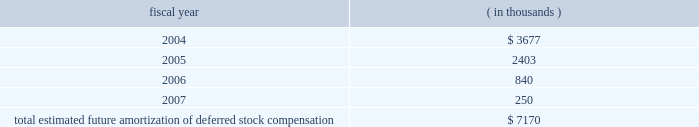The table presents the estimated future amortization of deferred stock compensation reported in both cost of revenue and operating expenses : fiscal year ( in thousands ) .
Impairment of intangible assets .
In fiscal 2002 , we recognized an aggregate impairment charge of $ 3.8 million to reduce the amount of certain intangible assets associated with prior acquisitions to their estimated fair value .
Approximately $ 3.7 million and $ 0.1 million are included in integration expense and amortization of intangible assets , respectively , on the consolidated statement of operations .
The impairment charge is primarily attributable to certain technology acquired from and goodwill related to the acquisition of stanza , inc .
( stanza ) in 1999 .
During fiscal 2002 , we determined that we would not allocate future resources to assist in the market growth of this technology as products acquired in the merger with avant! provided customers with superior capabilities .
As a result , we do not anticipate any future sales of the stanza product .
In fiscal 2001 , we recognized an aggregate impairment charge of $ 2.2 million to reduce the amount of certain intangible assets associated with prior acquisitions to their estimated fair value .
Approximately $ 1.8 million and $ 0.4 million are included in cost of revenues and amortization of intangible assets , respectively , on the consolidated statement of operations .
The impairment charge is attributable to certain technology acquired from and goodwill related to the acquisition of eagle design automation , inc .
( eagle ) in 1997 .
During fiscal 2001 , we determined that we would not allocate future resources to assist in the market growth of this technology .
As a result , we do not anticipate any future sales of the eagle product .
There were no impairment charges during fiscal 2003 .
Other ( expense ) income , net .
Other income , net was $ 24.1 million in fiscal 2003 and consisted primarily of ( i ) realized gain on investments of $ 20.7 million ; ( ii ) rental income of $ 6.3 million ; ( iii ) interest income of $ 5.2 million ; ( iv ) impairment charges related to certain assets in our venture portfolio of ( $ 4.5 ) million ; ( vii ) foundation contributions of ( $ 2.1 ) million ; and ( viii ) interest expense of ( $ 1.6 ) million .
Other ( expense ) , net of other income was ( $ 208.6 ) million in fiscal 2002 and consisted primarily of ( i ) ( $ 240.8 ) million expense due to the settlement of the cadence design systems , inc .
( cadence ) litigation ; ( ii ) ( $ 11.3 ) million in impairment charges related to certain assets in our venture portfolio ; ( iii ) realized gains on investments of $ 22.7 million ; ( iv ) a gain of $ 3.1 million for the termination fee on the ikos systems , inc .
( ikos ) merger agreement ; ( v ) rental income of $ 10.0 million ; ( vi ) interest income of $ 8.3 million ; and ( vii ) and other miscellaneous expenses including amortization of premium forwards and foreign exchange gains and losses recognized during the fiscal year of ( $ 0.6 ) million .
Other income , net was $ 83.8 million in fiscal 2001 and consisted primarily of ( i ) a gain of $ 10.6 million on the sale of our silicon libraries business to artisan components , inc. ; ( ii ) ( $ 5.8 ) million in impairment charges related to certain assets in our venture portfolio ; ( iii ) realized gains on investments of $ 55.3 million ; ( iv ) rental income of $ 8.6 million ; ( v ) interest income of $ 12.8 million ; and ( vi ) other miscellaneous income including amortization of premium forwards and foreign exchange gains and losses recognized during the fiscal year of $ 2.3 million .
Termination of agreement to acquire ikos systems , inc .
On july 2 , 2001 , we entered into an agreement and plan of merger and reorganization ( the ikos merger agreement ) with ikos systems , inc .
The ikos merger agreement provided for the acquisition of all outstanding shares of ikos common stock by synopsys. .
Considering the years 2004-2005 , what is the percentual decrease observed in the estimated future amortization of deferred stock compensation? 
Rationale: it is the variation between those values divided by the initial one , then turned into a percentage .
Computations: ((2403 - 3677) / 3677)
Answer: -0.34648. 